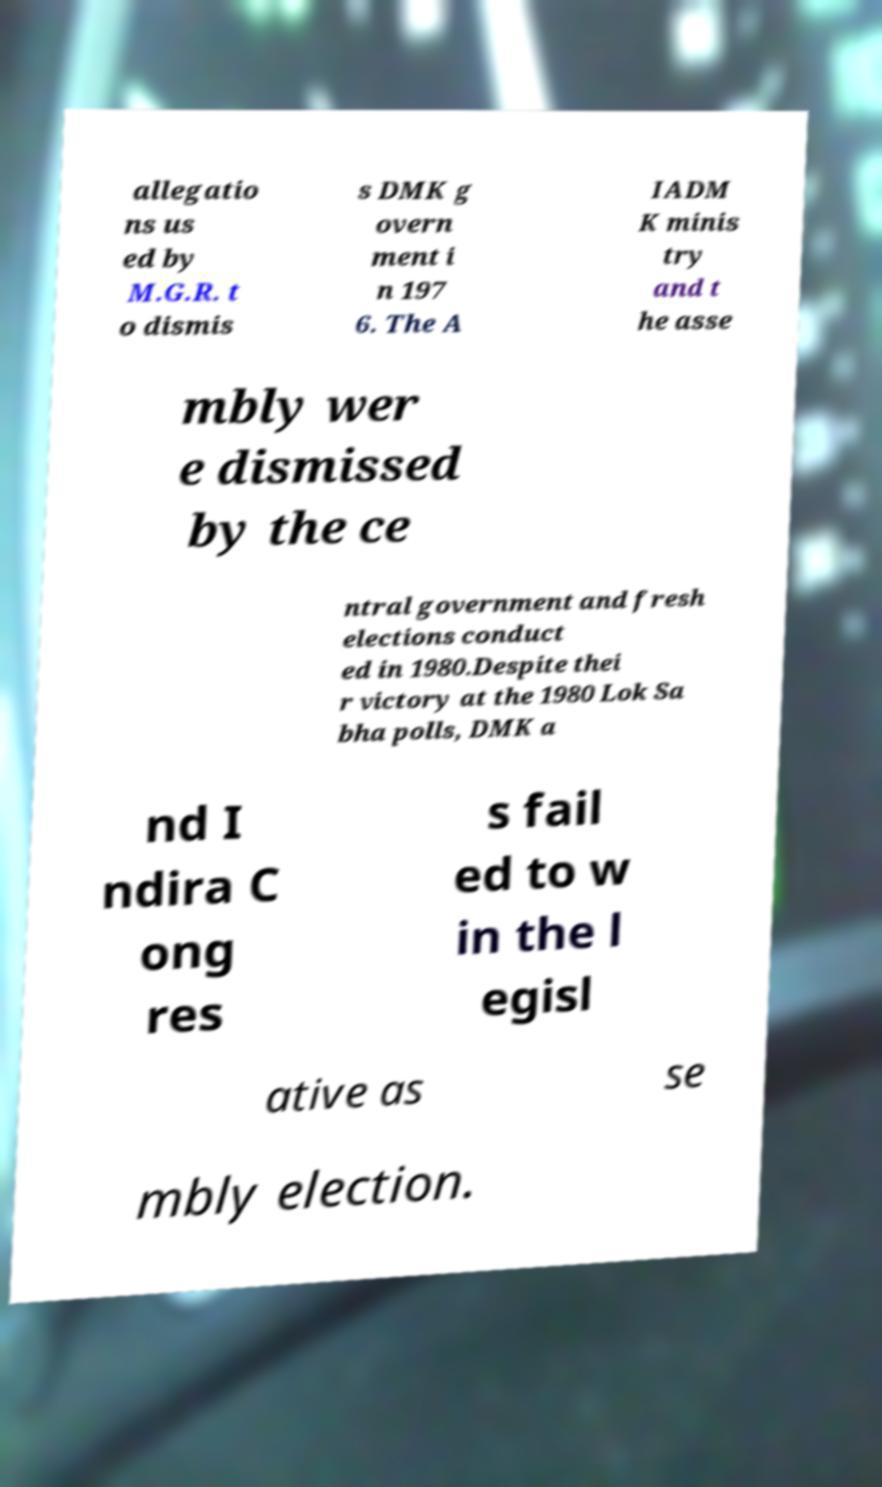I need the written content from this picture converted into text. Can you do that? allegatio ns us ed by M.G.R. t o dismis s DMK g overn ment i n 197 6. The A IADM K minis try and t he asse mbly wer e dismissed by the ce ntral government and fresh elections conduct ed in 1980.Despite thei r victory at the 1980 Lok Sa bha polls, DMK a nd I ndira C ong res s fail ed to w in the l egisl ative as se mbly election. 